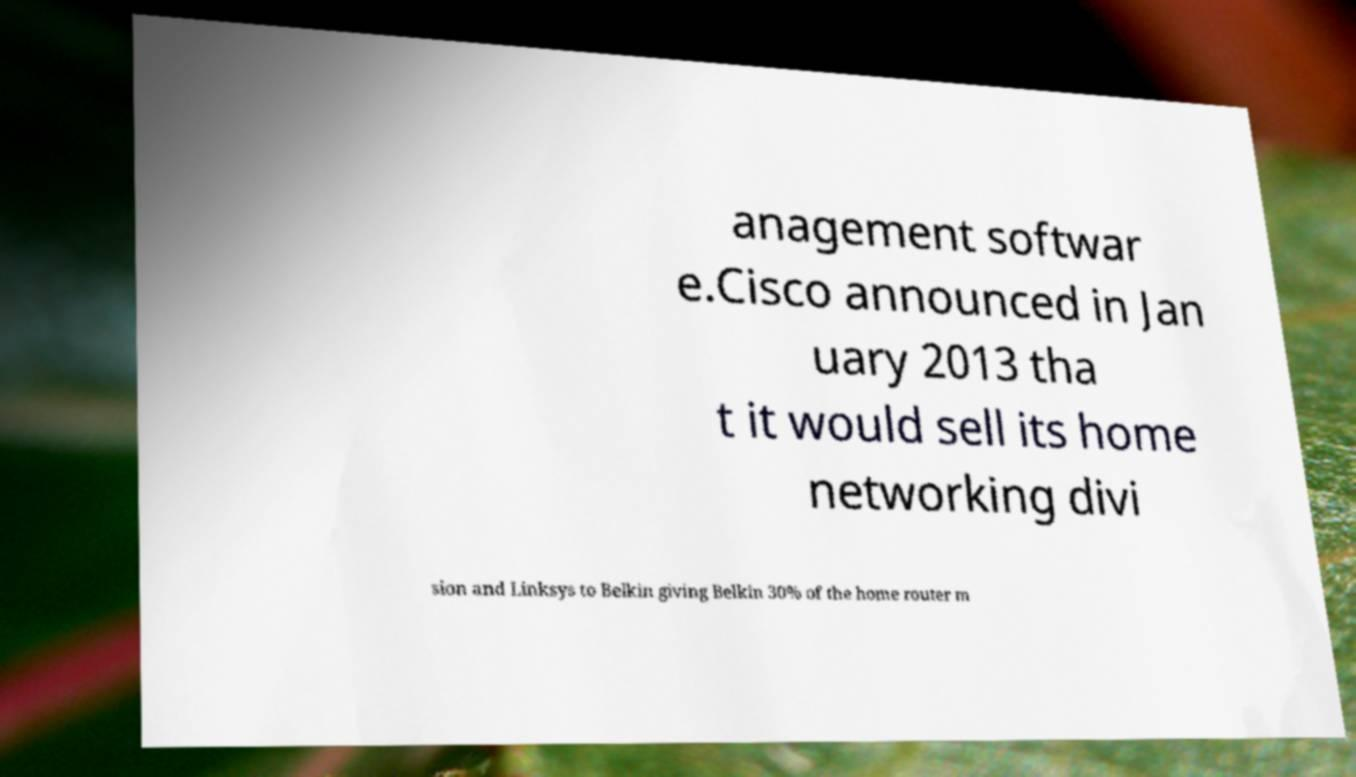What messages or text are displayed in this image? I need them in a readable, typed format. anagement softwar e.Cisco announced in Jan uary 2013 tha t it would sell its home networking divi sion and Linksys to Belkin giving Belkin 30% of the home router m 